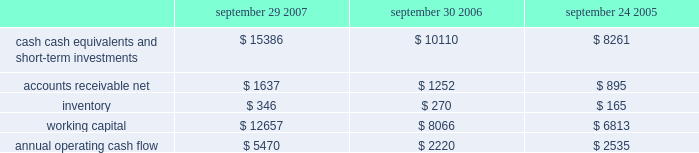No .
159 requires that unrealized gains and losses on items for which the fair value option has been elected be reported in earnings at each reporting date .
Sfas no .
159 is effective for fiscal years beginning after november 15 , 2007 and is required to be adopted by the company beginning in the first quarter of fiscal 2009 .
Although the company will continue to evaluate the application of sfas no .
159 , management does not currently believe adoption will have a material impact on the company 2019s financial condition or operating results .
In september 2006 , the fasb issued sfas no .
157 , fair value measurements , which defines fair value , provides a framework for measuring fair value , and expands the disclosures required for fair value measurements .
Sfas no .
157 applies to other accounting pronouncements that require fair value measurements ; it does not require any new fair value measurements .
Sfas no .
157 is effective for fiscal years beginning after november 15 , 2007 and is required to be adopted by the company beginning in the first quarter of fiscal 2009 .
Although the company will continue to evaluate the application of sfas no .
157 , management does not currently believe adoption will have a material impact on the company 2019s financial condition or operating results .
In june 2006 , the fasb issued fasb interpretation no .
( 2018 2018fin 2019 2019 ) 48 , accounting for uncertainty in income taxes-an interpretation of fasb statement no .
109 .
Fin 48 clarifies the accounting for uncertainty in income taxes by creating a framework for how companies should recognize , measure , present , and disclose in their financial statements uncertain tax positions that they have taken or expect to take in a tax return .
Fin 48 is effective for fiscal years beginning after december 15 , 2006 and is required to be adopted by the company beginning in the first quarter of fiscal 2008 .
Although the company will continue to evaluate the application of fin 48 , management does not currently believe adoption will have a material impact on the company 2019s financial condition or operating results .
Liquidity and capital resources the table presents selected financial information and statistics for each of the last three fiscal years ( dollars in millions ) : september 29 , september 30 , september 24 , 2007 2006 2005 .
As of september 29 , 2007 , the company had $ 15.4 billion in cash , cash equivalents , and short-term investments , an increase of $ 5.3 billion over the same balance at the end of september 30 , 2006 .
The principal components of this net increase were cash generated by operating activities of $ 5.5 billion , proceeds from the issuance of common stock under stock plans of $ 365 million and excess tax benefits from stock-based compensation of $ 377 million .
These increases were partially offset by payments for acquisitions of property , plant , and equipment of $ 735 million and payments for acquisitions of intangible assets of $ 251 million .
The company 2019s short-term investment portfolio is primarily invested in highly rated , liquid investments .
As of september 29 , 2007 and september 30 , 2006 , $ 6.5 billion and $ 4.1 billion , respectively , of the company 2019s cash , cash equivalents , and short-term investments were held by foreign subsidiaries and are generally based in u.s .
Dollar-denominated holdings .
The company believes its existing balances of cash , cash equivalents , and short-term investments will be sufficient to satisfy its working capital needs , capital expenditures , outstanding commitments , and other liquidity requirements associated with its existing operations over the next 12 months. .
What was the percentage change in inventory between 2005 and 2006? 
Computations: ((270 - 165) / 165)
Answer: 0.63636. 